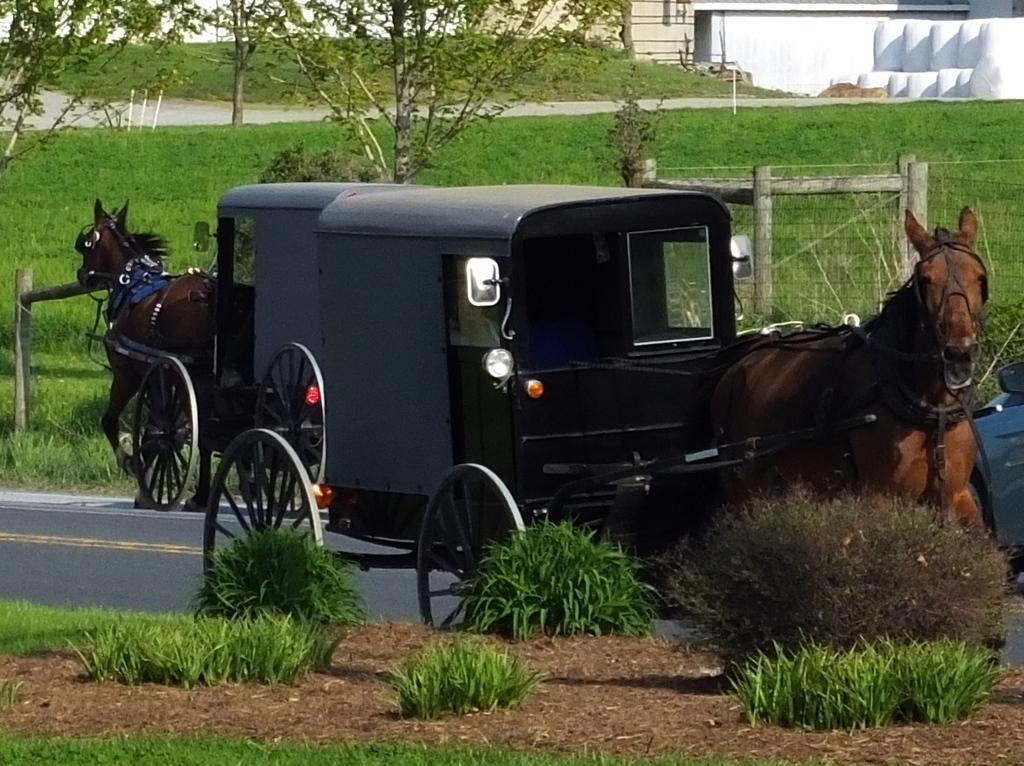In one or two sentences, can you explain what this image depicts? This picture is clicked outside. In the foreground we can see the grass. In the center we can see the horse cars running on the road. In the background we can see the trees, plants and some other items and the green grass. 